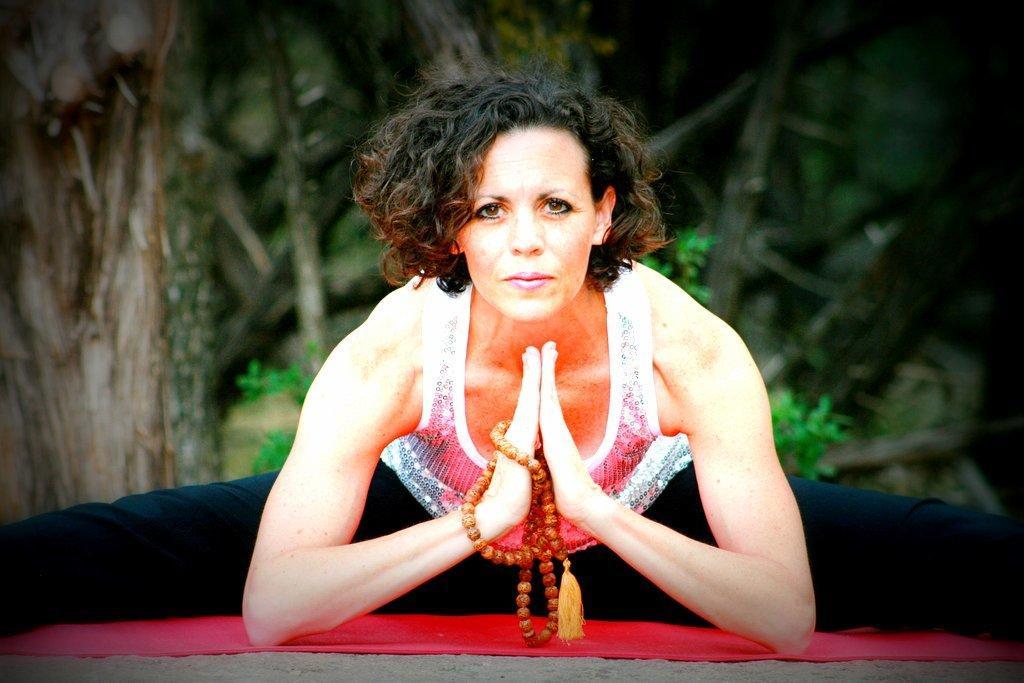Could you give a brief overview of what you see in this image? In this image there is a woman in the center doing yoga on the red mat which is present on the ground. In the background there are some trees. 